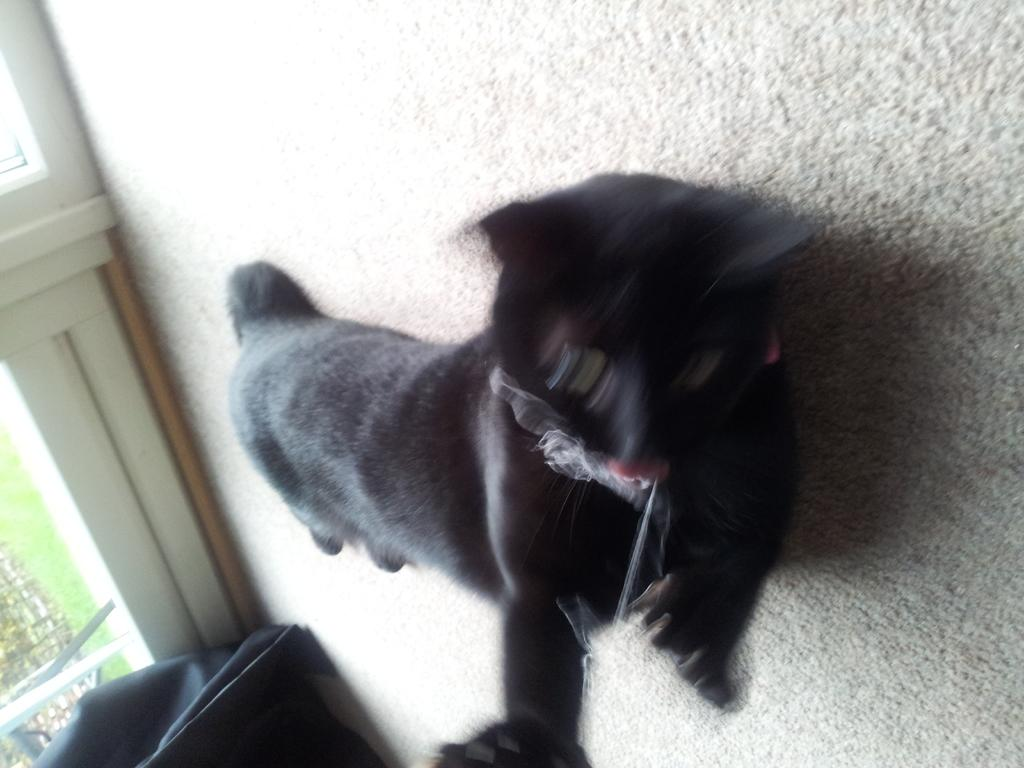What type of animal is in the image? There is an animal in the image, but its specific type cannot be determined from the provided facts. What color is the animal in the image? The animal is black in color. What can be seen in the background of the image? There is a black color object and a glass door in the background of the image. What is visible through the glass door? Grass is visible through the glass door. Is there a woman using a hose to water the grass in the image? There is no woman or hose present in the image; it only features an animal, a black color object, a glass door, and grass. 